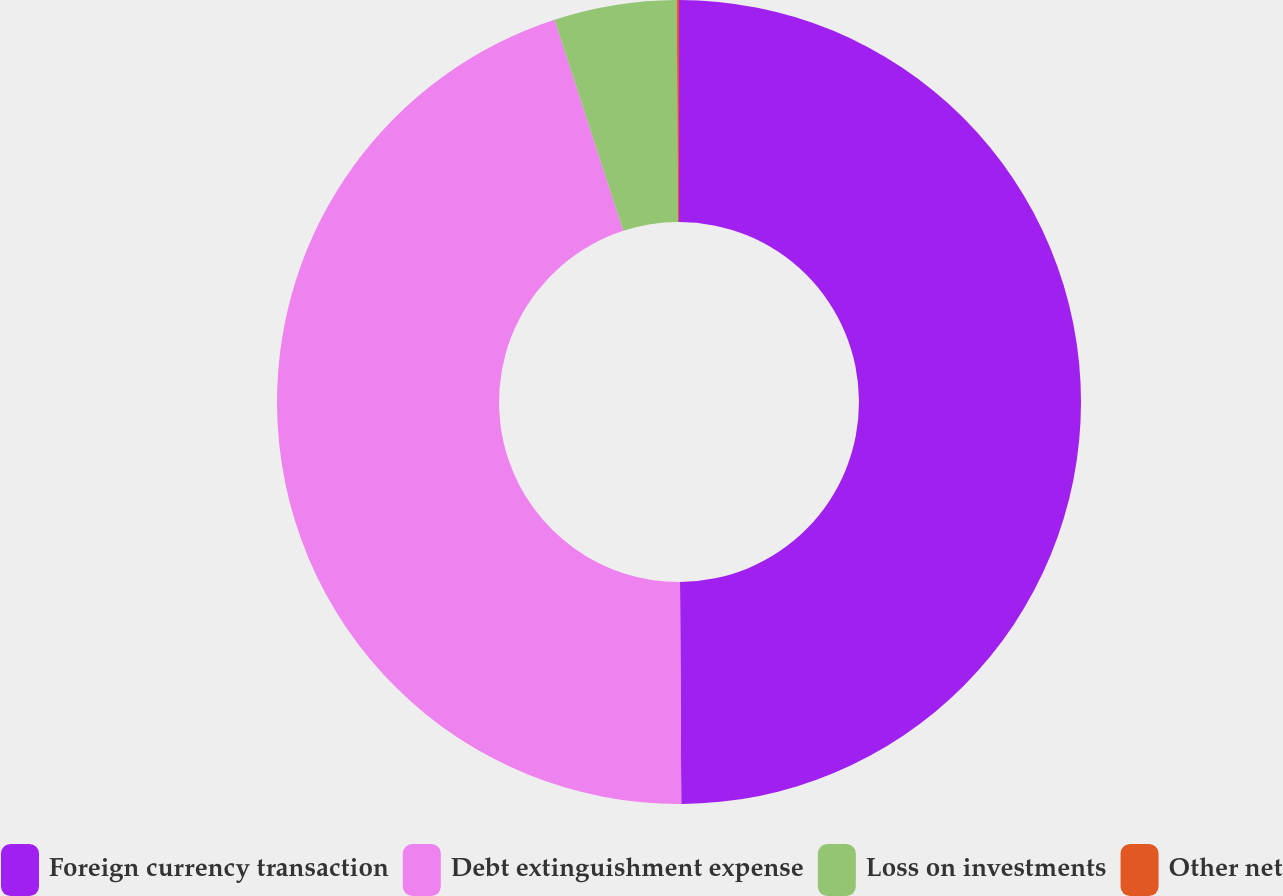Convert chart. <chart><loc_0><loc_0><loc_500><loc_500><pie_chart><fcel>Foreign currency transaction<fcel>Debt extinguishment expense<fcel>Loss on investments<fcel>Other net<nl><fcel>49.91%<fcel>45.08%<fcel>4.92%<fcel>0.09%<nl></chart> 